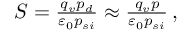<formula> <loc_0><loc_0><loc_500><loc_500>\begin{array} { r } { S = \frac { q _ { v } p _ { d } } { { \varepsilon } _ { 0 } p _ { s i } } \approx \frac { q _ { v } p } { { \varepsilon } _ { 0 } p _ { s i } } \, , } \end{array}</formula> 